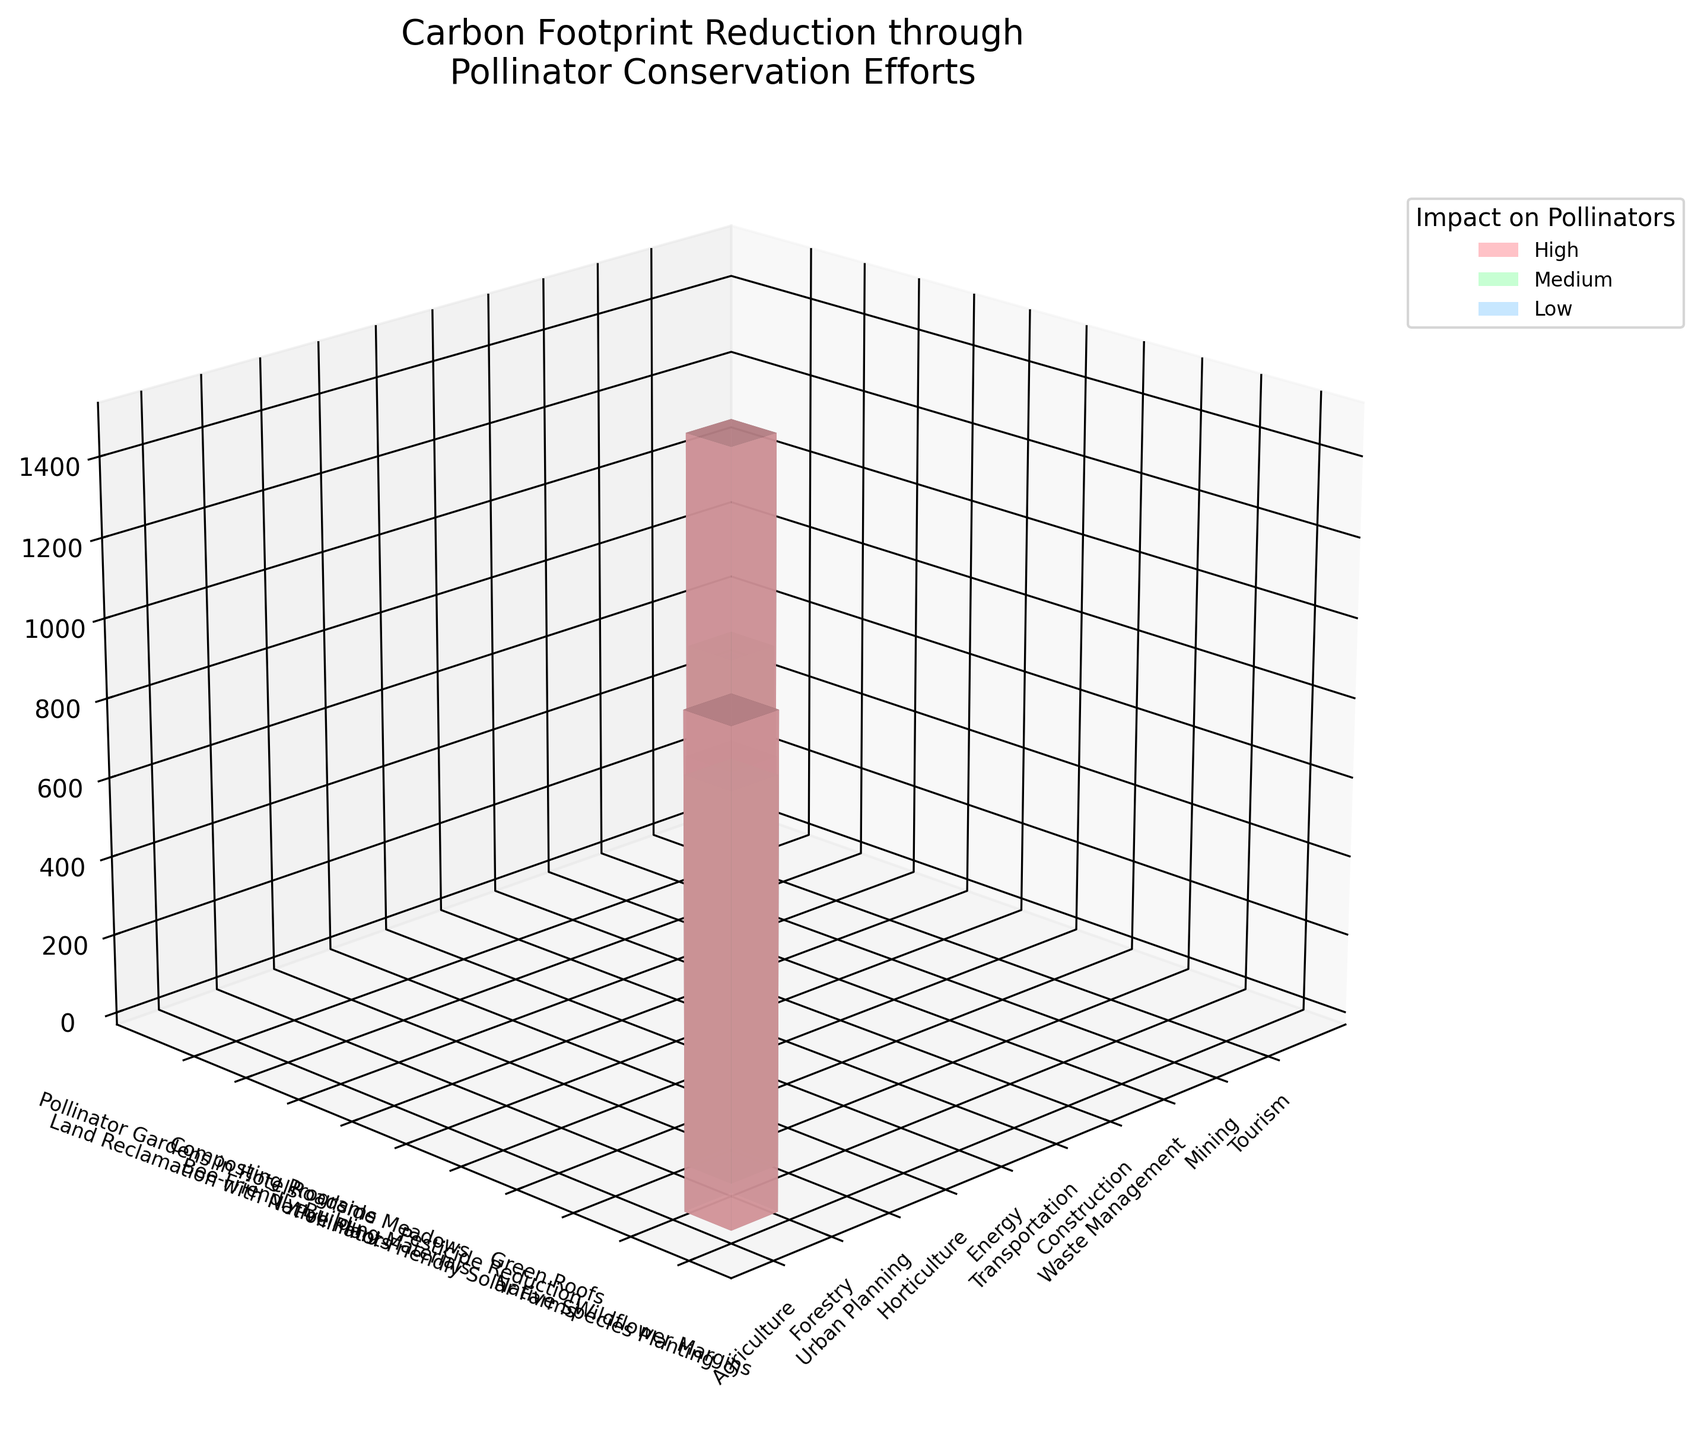What's the title of the figure? The title is located at the top of the figure and describes what the figure is about.
Answer: Carbon Footprint Reduction through Pollinator Conservation Efforts How many industries are represented in the figure? Each industry name is displayed along the horizontal axis, and we can count them to get the total number.
Answer: 10 Which industry shows the highest carbon reduction? By comparing the bar heights of each industry, we can see which one extends the highest value on the vertical axis.
Answer: Energy Which pollinator conservation effort is associated with the highest impact on pollinators? The color code in the legend helps identify which conservation efforts have a 'High' impact. Correspondingly, we check the bar colors in the figure.
Answer: Wildflower Margins, Pesticide Reduction, Pollinator-Friendly Solar Farms What is the difference in carbon reduction between Agriculture and Urban Planning? We find the heights of the bars labeled Agriculture and Urban Planning and subtract the latter's value from the former's.
Answer: 600 tons CO2 Which industry and conservation effort combination has the lowest carbon reduction? By looking at the shortest bar and verifying its labels for industry and conservation efforts, we can identify this combination.
Answer: Tourism, Pollinator Gardens in Hotels Which two industries have similar levels of carbon reduction and pollinator impact? By comparing bar heights and colors, we identify which pairs have close values and the same or similar color codes.
Answer: Urban Planning and Horticulture How does the carbon reduction achieved by Forestry compare to that of Mining? We locate and compare the bar heights for Forestry and Mining based on the vertical axis values.
Answer: Forestry is 400 tons CO2 higher than Mining What's the total carbon reduction achieved by the top three industries combined? Identifying the top three industries by the highest bar heights, we sum their carbon reduction values.
Answer: 1200 + 1500 + 950 = 3650 tons CO2 What's the median impact level for pollinators across the conservation efforts shown in the figure? Locate the median value in the sorted list of impact levels (High, Medium, Low) and determine the middle value.
Answer: Medium 